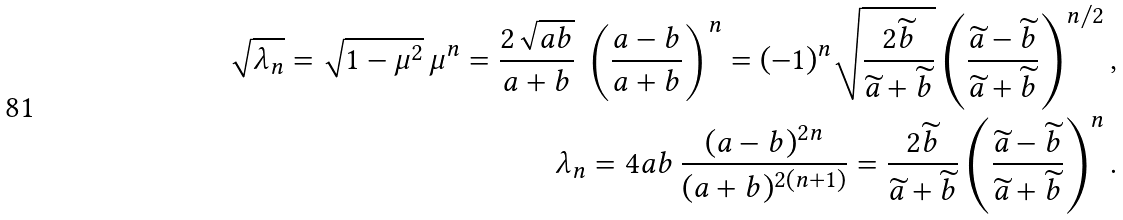<formula> <loc_0><loc_0><loc_500><loc_500>\sqrt { \lambda _ { n } } = \sqrt { 1 - \mu ^ { 2 } } \, \mu ^ { n } = \frac { 2 \sqrt { a b } } { a + b } \, \left ( \frac { a - b } { a + b } \right ) ^ { n } = ( - 1 ) ^ { n } \sqrt { \frac { 2 { \widetilde { b } } } { { \widetilde { a } } + { \widetilde { b } } } } \left ( \frac { { \widetilde { a } } - { \widetilde { b } } } { { \widetilde { a } } + { \widetilde { b } } } \right ) ^ { n / 2 } , \\ \lambda _ { n } = 4 a b \, \frac { ( a - b ) ^ { 2 n } } { ( a + b ) ^ { 2 ( n + 1 ) } } = \frac { 2 { \widetilde { b } } } { { \widetilde { a } } + { \widetilde { b } } } \left ( \frac { { \widetilde { a } } - { \widetilde { b } } } { { \widetilde { a } } + { \widetilde { b } } } \right ) ^ { n } .</formula> 